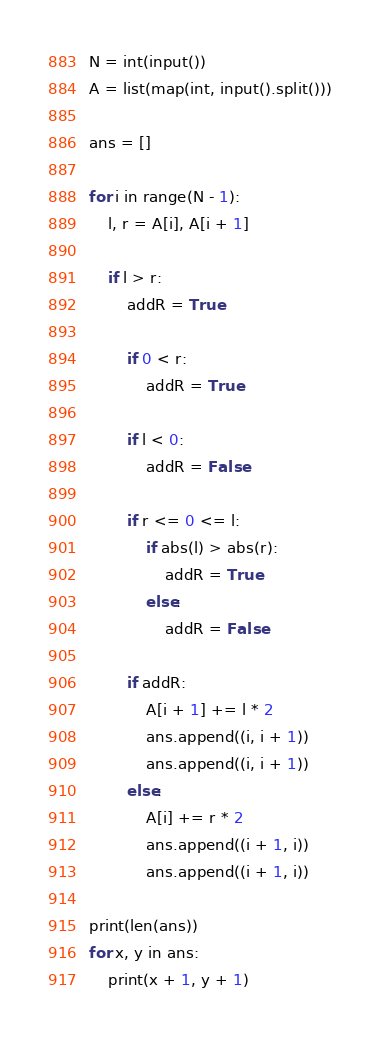<code> <loc_0><loc_0><loc_500><loc_500><_Python_>N = int(input())
A = list(map(int, input().split()))

ans = []

for i in range(N - 1):
    l, r = A[i], A[i + 1]

    if l > r:
        addR = True

        if 0 < r:
            addR = True

        if l < 0:
            addR = False

        if r <= 0 <= l:
            if abs(l) > abs(r):
                addR = True
            else:
                addR = False

        if addR:
            A[i + 1] += l * 2
            ans.append((i, i + 1))
            ans.append((i, i + 1))
        else:
            A[i] += r * 2
            ans.append((i + 1, i))
            ans.append((i + 1, i))

print(len(ans))
for x, y in ans:
    print(x + 1, y + 1)
</code> 